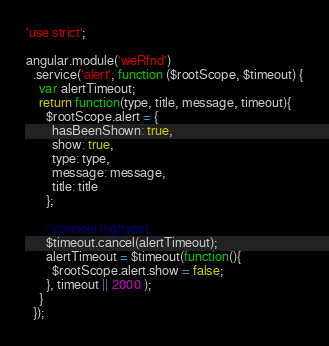Convert code to text. <code><loc_0><loc_0><loc_500><loc_500><_JavaScript_>'use strict';

angular.module('weRfnd')
  .service('alert', function ($rootScope, $timeout) {
    var alertTimeout;
    return function(type, title, message, timeout){
      $rootScope.alert = {
        hasBeenShown: true,
        show: true,
        type: type,
        message: message,
        title: title
      };

      //console.log(type);
      $timeout.cancel(alertTimeout);
      alertTimeout = $timeout(function(){
        $rootScope.alert.show = false;
      }, timeout || 2000 );
    }
  });
</code> 